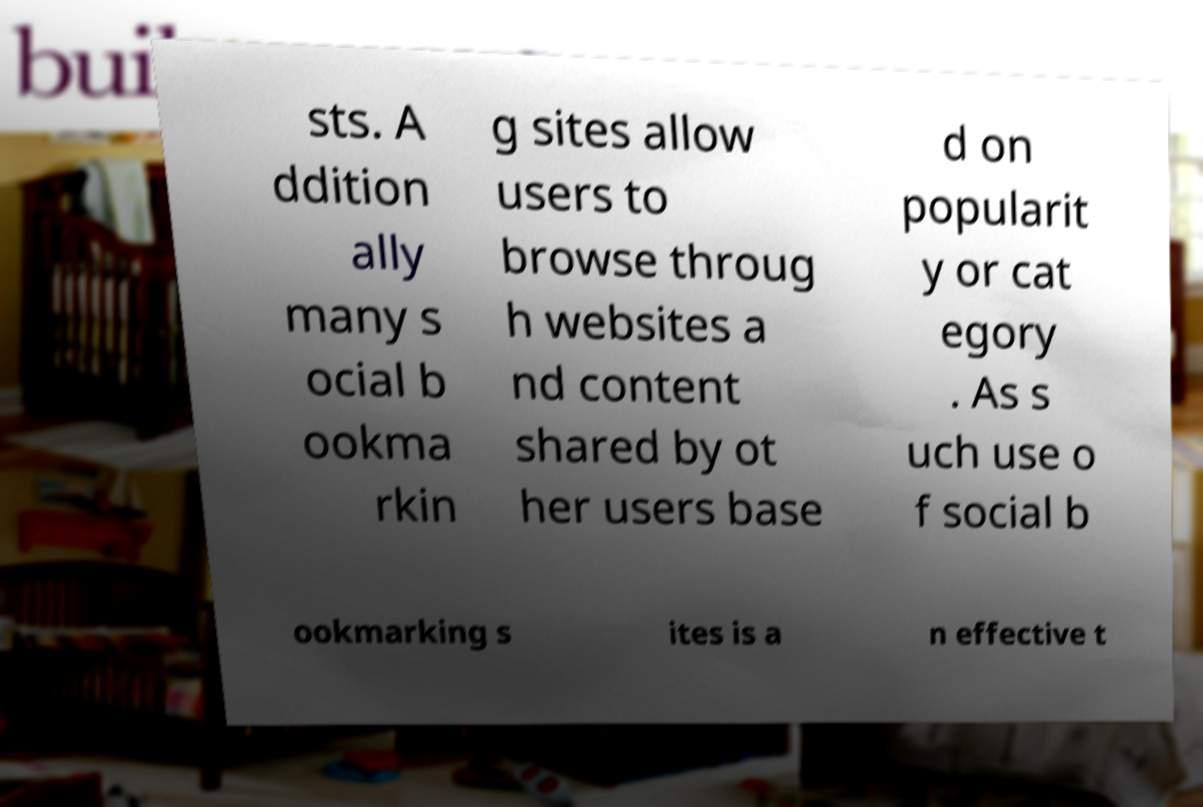Please identify and transcribe the text found in this image. sts. A ddition ally many s ocial b ookma rkin g sites allow users to browse throug h websites a nd content shared by ot her users base d on popularit y or cat egory . As s uch use o f social b ookmarking s ites is a n effective t 